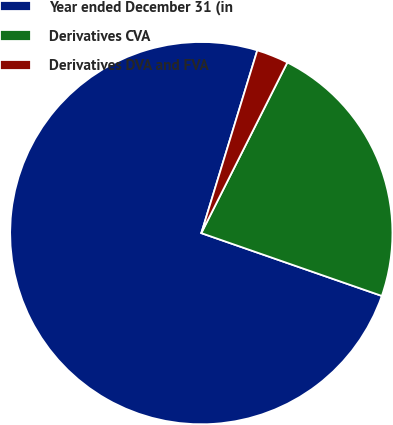Convert chart. <chart><loc_0><loc_0><loc_500><loc_500><pie_chart><fcel>Year ended December 31 (in<fcel>Derivatives CVA<fcel>Derivatives DVA and FVA<nl><fcel>74.41%<fcel>22.9%<fcel>2.7%<nl></chart> 